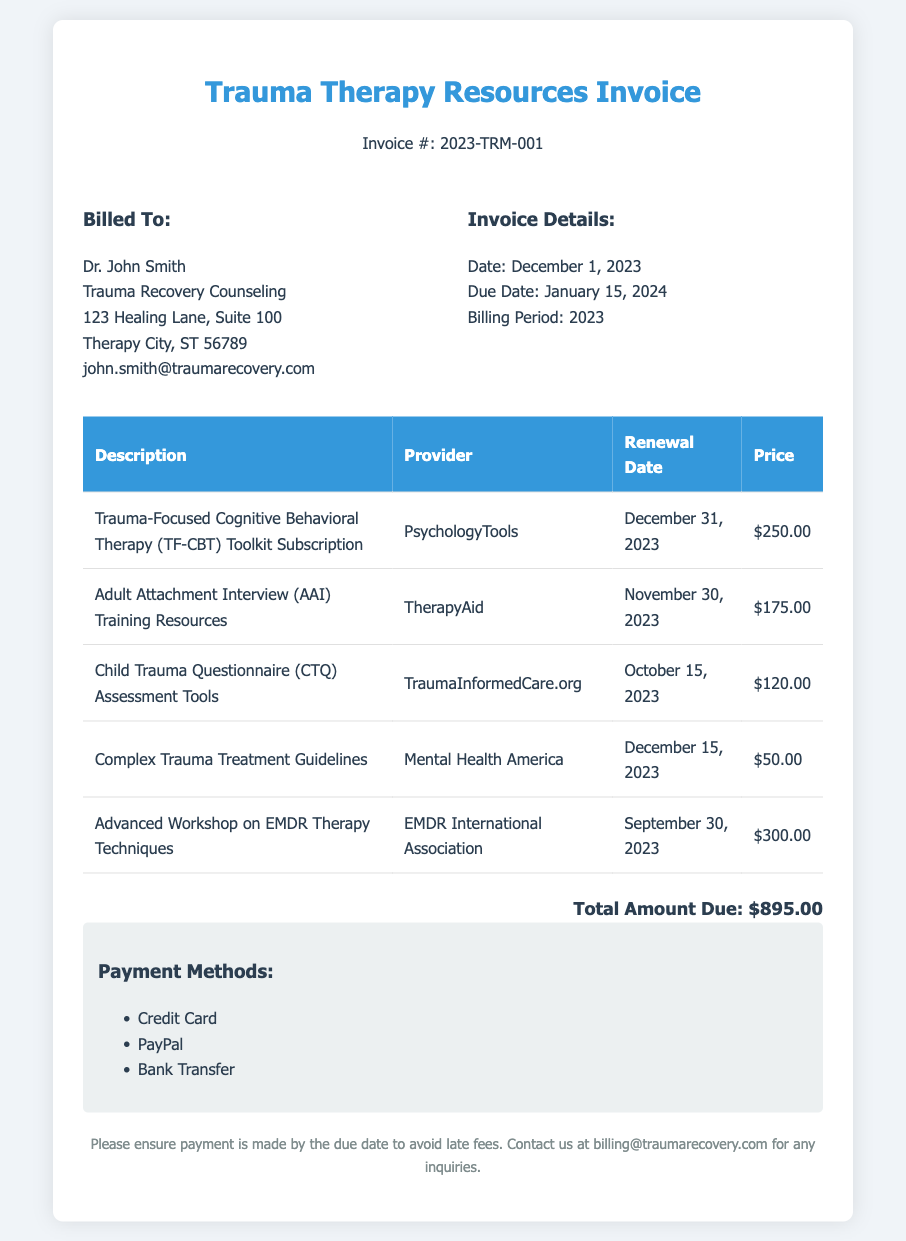What is the invoice number? The invoice number is indicated near the top of the document.
Answer: 2023-TRM-001 Who is billed for the services? The "Billed To" section provides the name and organization of the client.
Answer: Dr. John Smith What is the total amount due? The total amount due is summarized at the bottom of the invoice.
Answer: $895.00 What is the renewal date for the TF-CBT Toolkit Subscription? The renewal date for this subscription is listed in the table of resources.
Answer: December 31, 2023 How many different resources are included in the invoice? The number of resources can be counted from the rows in the table.
Answer: 5 What is the due date for the invoice? The due date is specified in the invoice details section.
Answer: January 15, 2024 Which provider offers the Child Trauma Questionnaire? The provider for this tool is mentioned in the second column of the table.
Answer: TraumaInformedCare.org Is there a payment method specified in the document? The payment methods are listed towards the end of the invoice.
Answer: Yes What is the price of the Adult Attachment Interview training resources? The price is detailed in the pricing column of the resources table.
Answer: $175.00 